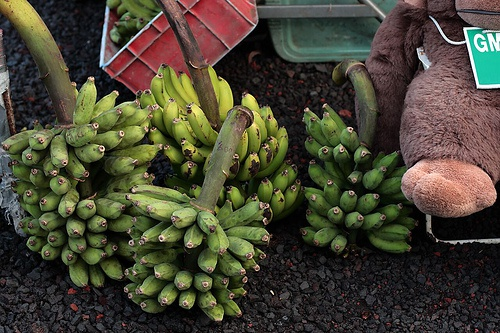Describe the objects in this image and their specific colors. I can see teddy bear in olive, brown, black, gray, and maroon tones, banana in olive, black, and darkgreen tones, banana in olive, black, and darkgreen tones, banana in olive, black, and darkgreen tones, and banana in olive, black, and darkgreen tones in this image. 